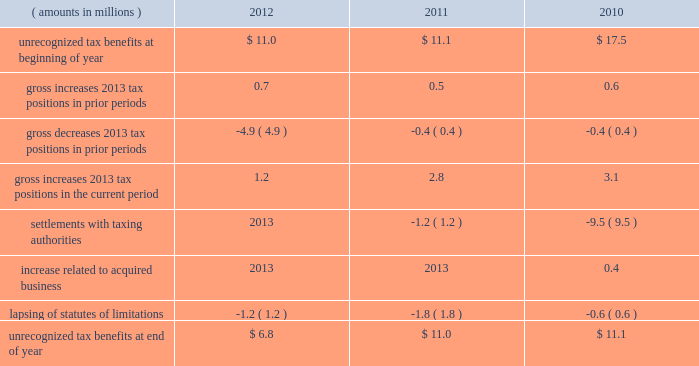A valuation allowance totaling $ 43.9 million , $ 40.4 million and $ 40.1 million as of 2012 , 2011 and 2010 year end , respectively , has been established for deferred income tax assets primarily related to certain subsidiary loss carryforwards that may not be realized .
Realization of the net deferred income tax assets is dependent on generating sufficient taxable income prior to their expiration .
Although realization is not assured , management believes it is more- likely-than-not that the net deferred income tax assets will be realized .
The amount of the net deferred income tax assets considered realizable , however , could change in the near term if estimates of future taxable income during the carryforward period fluctuate .
The following is a reconciliation of the beginning and ending amounts of unrecognized tax benefits for 2012 , 2011 and ( amounts in millions ) 2012 2011 2010 .
Of the $ 6.8 million , $ 11.0 million and $ 11.1 million of unrecognized tax benefits as of 2012 , 2011 and 2010 year end , respectively , approximately $ 4.1 million , $ 9.1 million and $ 11.1 million , respectively , would impact the effective income tax rate if recognized .
Interest and penalties related to unrecognized tax benefits are recorded in income tax expense .
During 2012 and 2011 , the company reversed a net $ 0.5 million and $ 1.4 million , respectively , of interest and penalties to income associated with unrecognized tax benefits .
As of 2012 , 2011 and 2010 year end , the company has provided for $ 1.6 million , $ 1.6 million and $ 2.8 million , respectively , of accrued interest and penalties related to unrecognized tax benefits .
The unrecognized tax benefits and related accrued interest and penalties are included in 201cother long-term liabilities 201d on the accompanying consolidated balance sheets .
Snap-on and its subsidiaries file income tax returns in the united states and in various state , local and foreign jurisdictions .
It is reasonably possible that certain unrecognized tax benefits may either be settled with taxing authorities or the statutes of limitations for such items may lapse within the next 12 months , causing snap-on 2019s gross unrecognized tax benefits to decrease by a range of zero to $ 2.4 million .
Over the next 12 months , snap-on anticipates taking uncertain tax positions on various tax returns for which the related tax benefit does not meet the recognition threshold .
Accordingly , snap-on 2019s gross unrecognized tax benefits may increase by a range of zero to $ 1.6 million over the next 12 months for uncertain tax positions expected to be taken in future tax filings .
With few exceptions , snap-on is no longer subject to u.s .
Federal and state/local income tax examinations by tax authorities for years prior to 2008 , and snap-on is no longer subject to non-u.s .
Income tax examinations by tax authorities for years prior to 2006 .
The undistributed earnings of all non-u.s .
Subsidiaries totaled $ 492.2 million , $ 416.4 million and $ 386.5 million as of 2012 , 2011 and 2010 year end , respectively .
Snap-on has not provided any deferred taxes on these undistributed earnings as it considers the undistributed earnings to be permanently invested .
Determination of the amount of unrecognized deferred income tax liability related to these earnings is not practicable .
2012 annual report 83 .
What was the average undistributed earnings of all non-u.s . subsidiaries from 2010 to 2012 in millions? 
Computations: ((((492.2 + 416.4) + 386.5) + 3) / 2)
Answer: 649.05. 